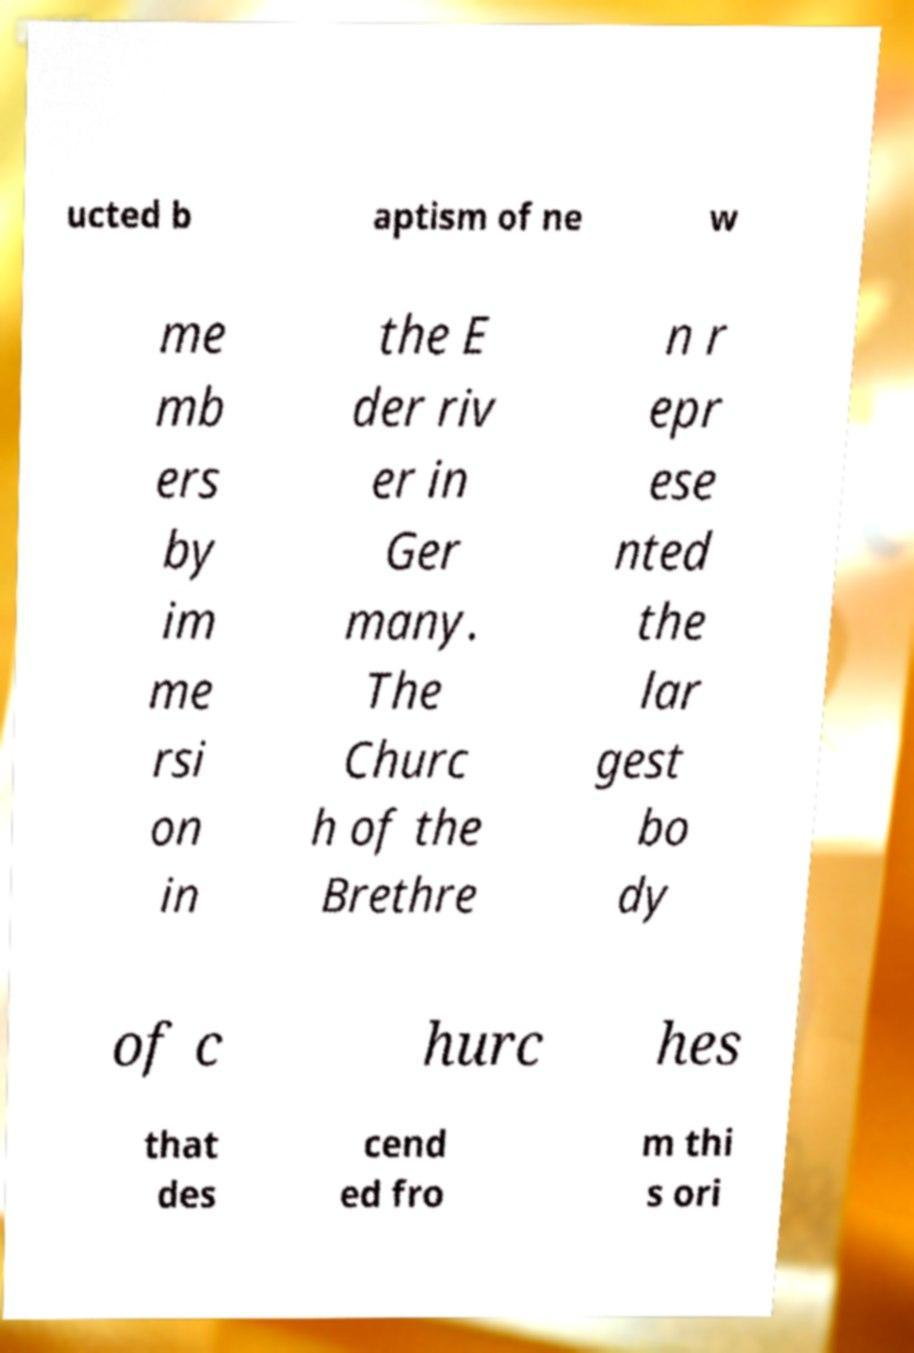Can you read and provide the text displayed in the image?This photo seems to have some interesting text. Can you extract and type it out for me? ucted b aptism of ne w me mb ers by im me rsi on in the E der riv er in Ger many. The Churc h of the Brethre n r epr ese nted the lar gest bo dy of c hurc hes that des cend ed fro m thi s ori 